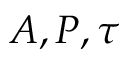Convert formula to latex. <formula><loc_0><loc_0><loc_500><loc_500>A , P , \tau</formula> 